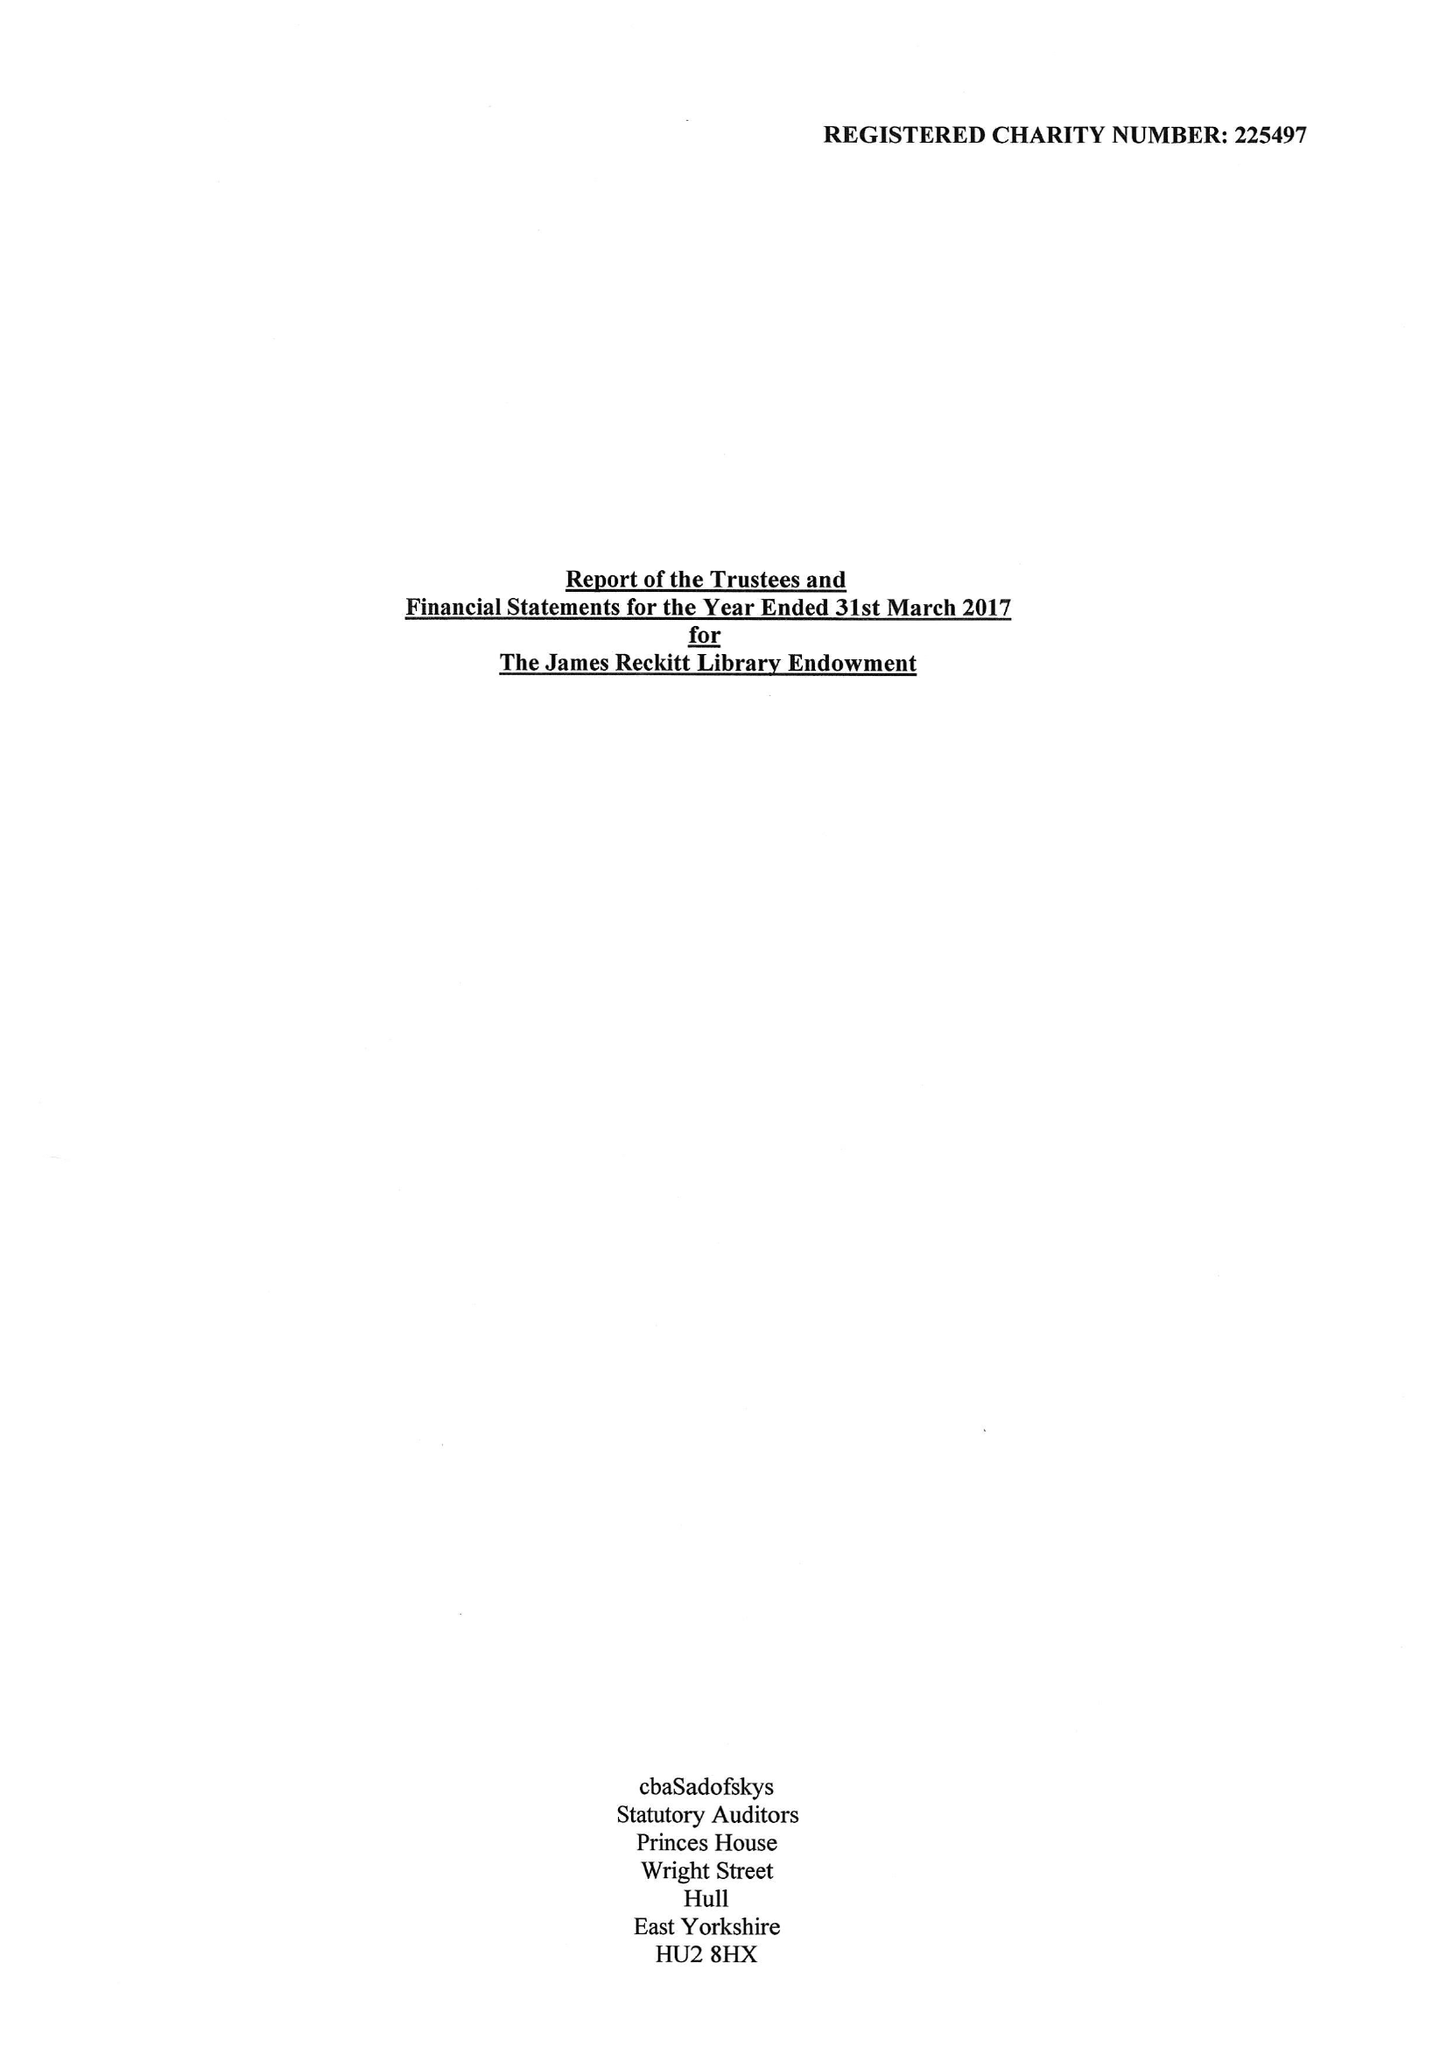What is the value for the spending_annually_in_british_pounds?
Answer the question using a single word or phrase. 525928.00 